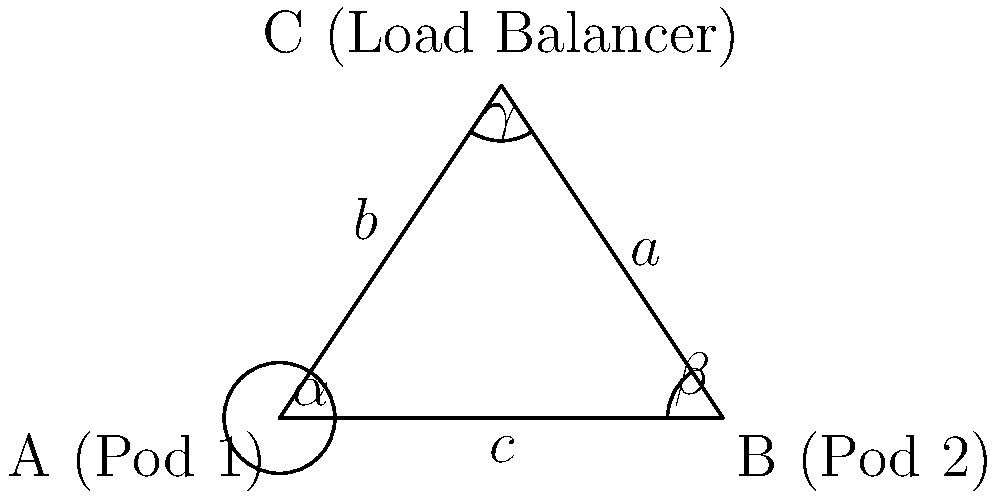In a Kubernetes cluster, three nodes form a triangle-shaped network topology. Pod 1 is at point A, Pod 2 is at point B, and the load balancer is at point C. The distance between Pod 1 and Pod 2 (side $c$) is 100 ms in network latency. The angle at the load balancer ($\gamma$) is 60°, and the angle at Pod 1 ($\alpha$) is 45°. Using the law of sines, calculate the network latency between Pod 2 and the load balancer (side $a$) in milliseconds. To solve this problem, we'll use the law of sines and follow these steps:

1) The law of sines states that:
   $$\frac{a}{\sin(A)} = \frac{b}{\sin(B)} = \frac{c}{\sin(C)}$$

2) We know:
   - $c = 100$ ms
   - $\gamma = 60°$
   - $\alpha = 45°$

3) Calculate $\beta$:
   $\alpha + \beta + \gamma = 180°$
   $45° + \beta + 60° = 180°$
   $\beta = 75°$

4) Use the law of sines to find $a$:
   $$\frac{a}{\sin(60°)} = \frac{100}{\sin(45°)}$$

5) Solve for $a$:
   $$a = \frac{100 \sin(60°)}{\sin(45°)}$$

6) Calculate the result:
   $$a = \frac{100 \cdot \frac{\sqrt{3}}{2}}{\frac{\sqrt{2}}{2}} = 100 \cdot \frac{\sqrt{3}}{\sqrt{2}} \approx 122.47$$

Therefore, the network latency between Pod 2 and the load balancer is approximately 122.47 ms.
Answer: 122.47 ms 